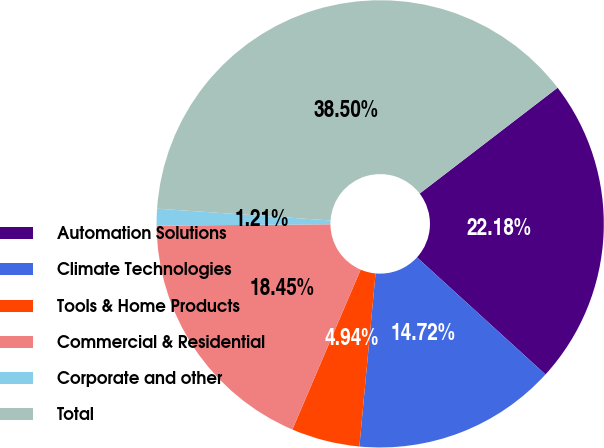<chart> <loc_0><loc_0><loc_500><loc_500><pie_chart><fcel>Automation Solutions<fcel>Climate Technologies<fcel>Tools & Home Products<fcel>Commercial & Residential<fcel>Corporate and other<fcel>Total<nl><fcel>22.18%<fcel>14.72%<fcel>4.94%<fcel>18.45%<fcel>1.21%<fcel>38.5%<nl></chart> 